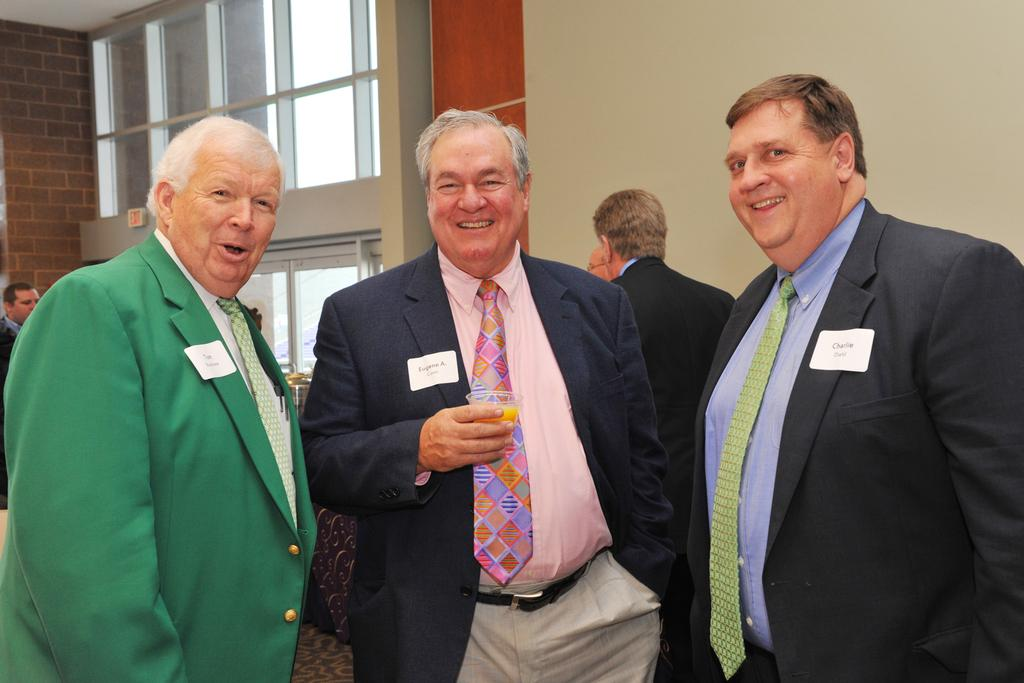How many men in suits can be seen in the foreground of the image? There are three men in suits in the foreground of the image. What is one of the men holding? One man is holding a glass. Can you describe the background of the image? There are men in the background of the image, along with a wall and glass windows. What type of stem can be seen growing from the glass in the image? There is no stem growing from the glass in the image; it is a man holding a glass. What is the nature of the argument between the men in the background of the image? There is no argument depicted in the image; it only shows men in the background. 